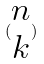Convert formula to latex. <formula><loc_0><loc_0><loc_500><loc_500>( \begin{matrix} n \\ k \end{matrix} )</formula> 